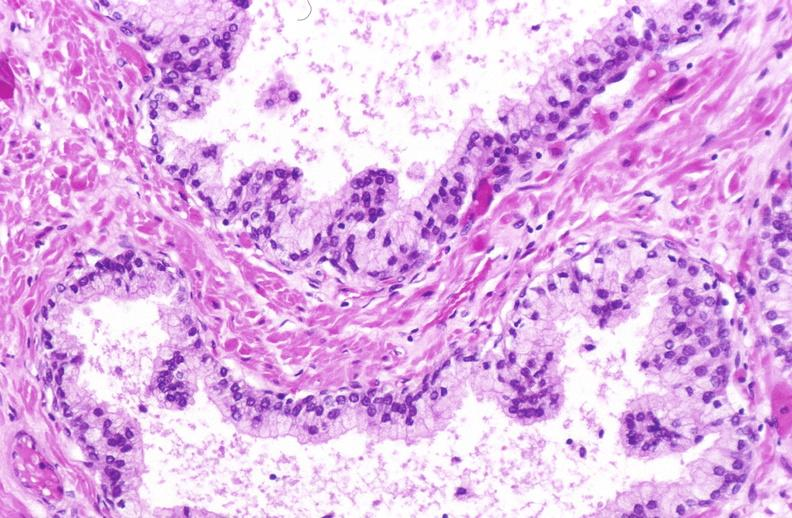what does this image show?
Answer the question using a single word or phrase. Normal prostate 